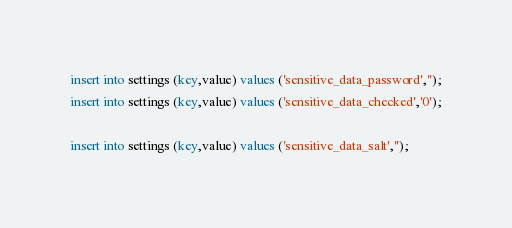Convert code to text. <code><loc_0><loc_0><loc_500><loc_500><_SQL_>insert into settings (key,value) values ('sensitive_data_password','');
insert into settings (key,value) values ('sensitive_data_checked','0');

insert into settings (key,value) values ('sensitive_data_salt','');</code> 